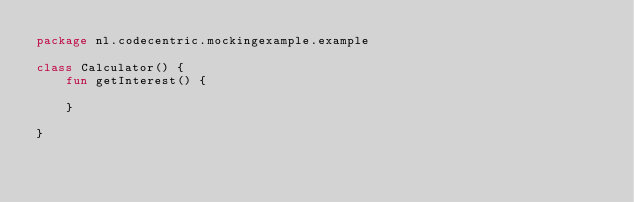<code> <loc_0><loc_0><loc_500><loc_500><_Kotlin_>package nl.codecentric.mockingexample.example

class Calculator() {
    fun getInterest() {

    }

}</code> 